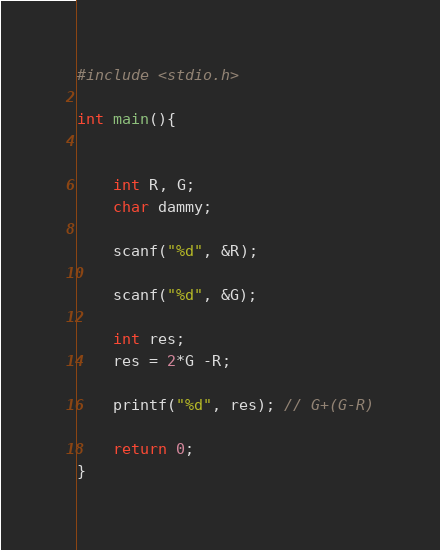Convert code to text. <code><loc_0><loc_0><loc_500><loc_500><_C_>#include <stdio.h>

int main(){

    
    int R, G;
    char dammy;
    
    scanf("%d", &R);

    scanf("%d", &G);

    int res;
    res = 2*G -R;

    printf("%d", res); // G+(G-R)

    return 0;
}</code> 